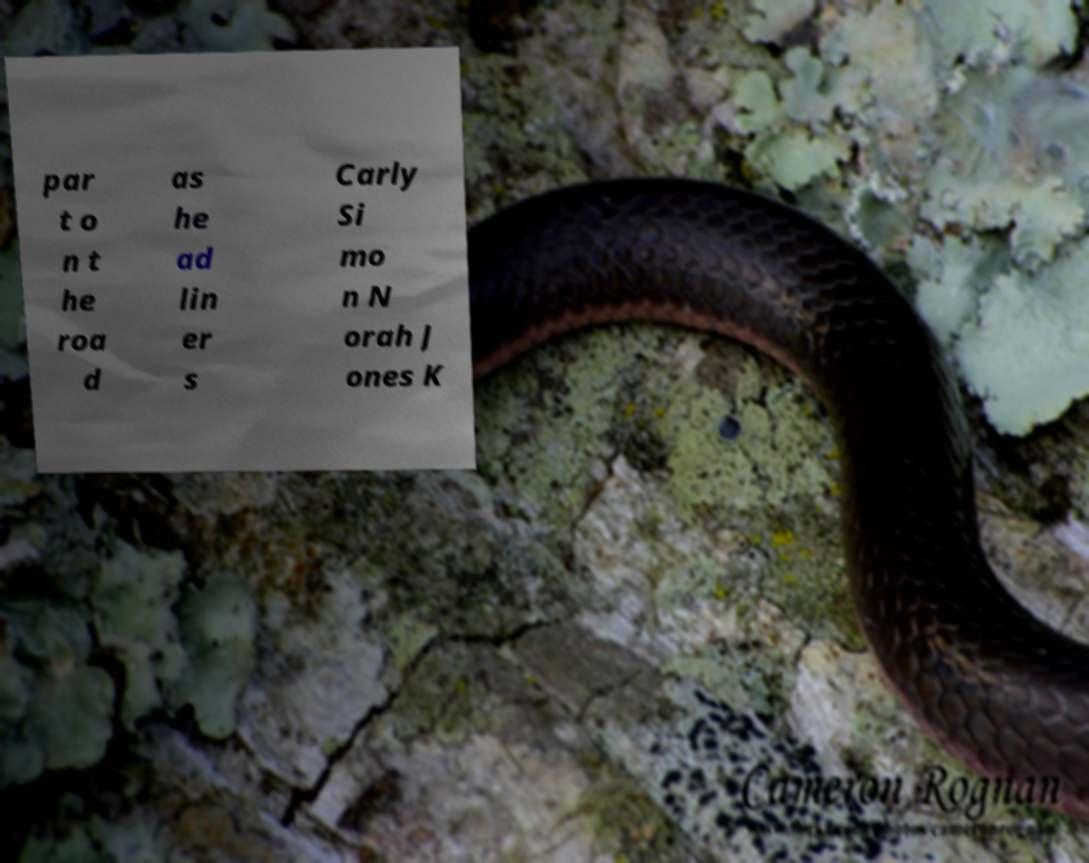Can you accurately transcribe the text from the provided image for me? par t o n t he roa d as he ad lin er s Carly Si mo n N orah J ones K 